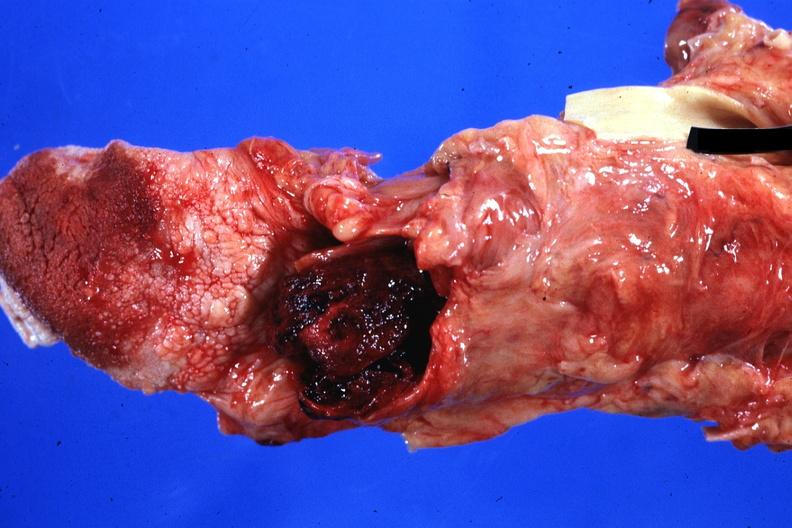what is present?
Answer the question using a single word or phrase. Larynx 